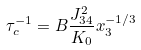<formula> <loc_0><loc_0><loc_500><loc_500>\tau _ { c } ^ { - 1 } = B \frac { J _ { 3 4 } ^ { 2 } } { K _ { 0 } } x _ { 3 } ^ { - 1 / 3 }</formula> 